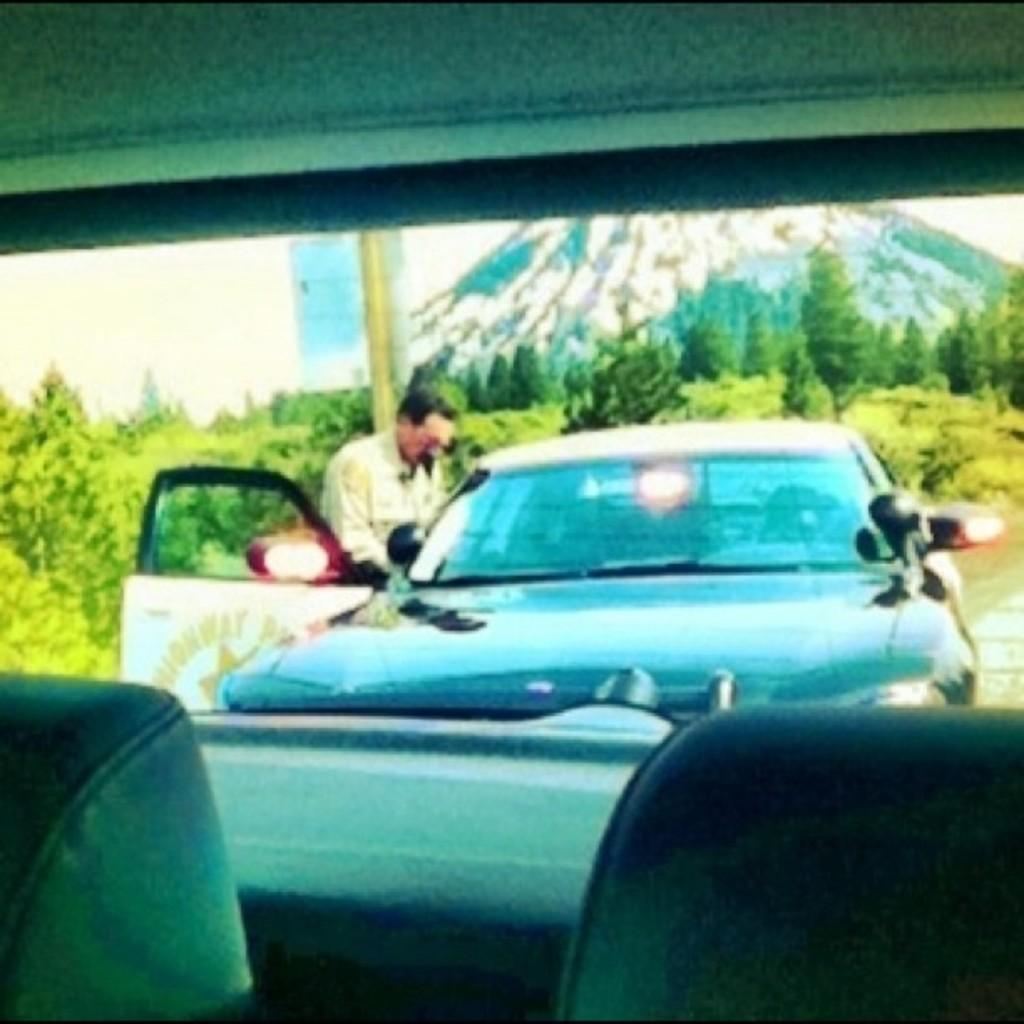What type of vehicle is shown in the image? The image shows the inside view of a car. Can you describe the setting of the image? The image shows the inside of a car, with a person present, and trees and a mountain visible in the background. What is the person in the image doing? The facts provided do not specify what the person is doing in the image. What can be seen outside the car in the image? Trees and a mountain are visible in the background of the image. What type of light is hanging from the ceiling in the image? There is no light hanging from the ceiling in the image; it shows the inside view of a car. How many bags can be seen in the image? There is no mention of bags in the image; it shows the inside view of a car with a person and a background of trees and a mountain. 